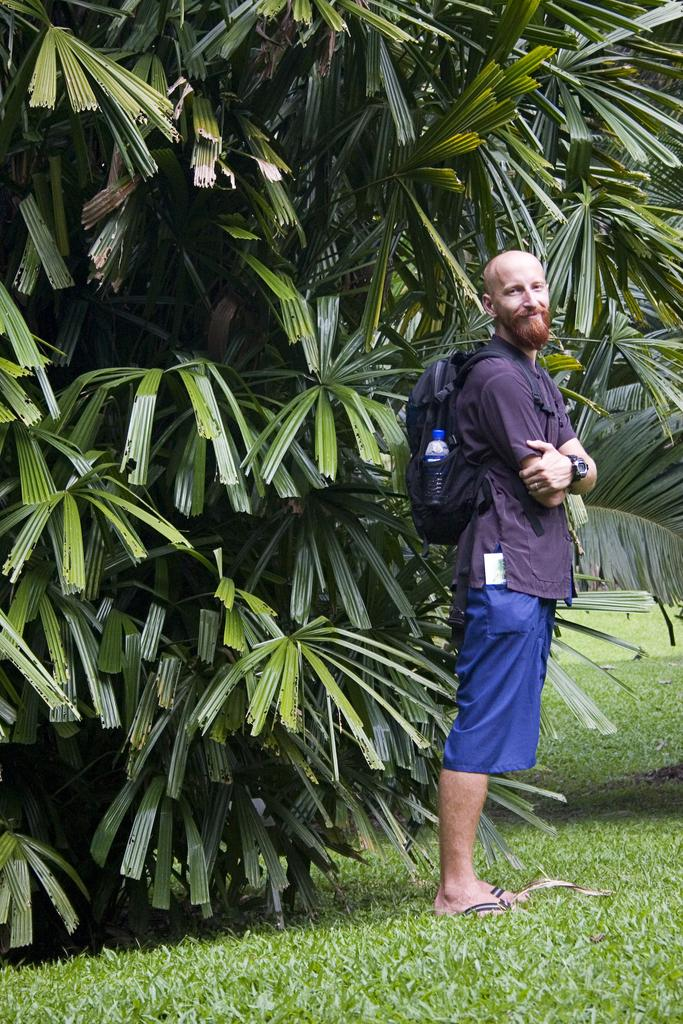Who or what is present in the image? There is a person in the image. What is the person wearing? The person is wearing a backpack. What is the person's position in relation to the ground? The person is standing on the ground. What can be seen in the background of the image? There are trees in the background of the image. What type of skirt is the person wearing in the image? There is no skirt present in the image; the person is wearing a backpack. 